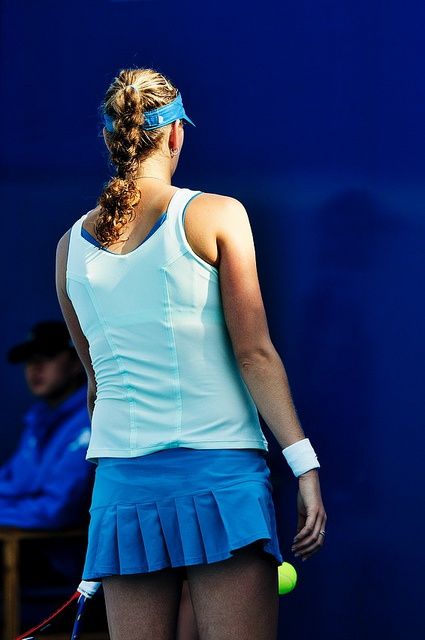Describe the objects in this image and their specific colors. I can see people in navy, lightblue, black, blue, and ivory tones, people in navy, black, darkblue, and maroon tones, chair in navy, black, maroon, and darkblue tones, tennis racket in navy, black, brown, and maroon tones, and sports ball in navy, lightgreen, khaki, green, and lime tones in this image. 